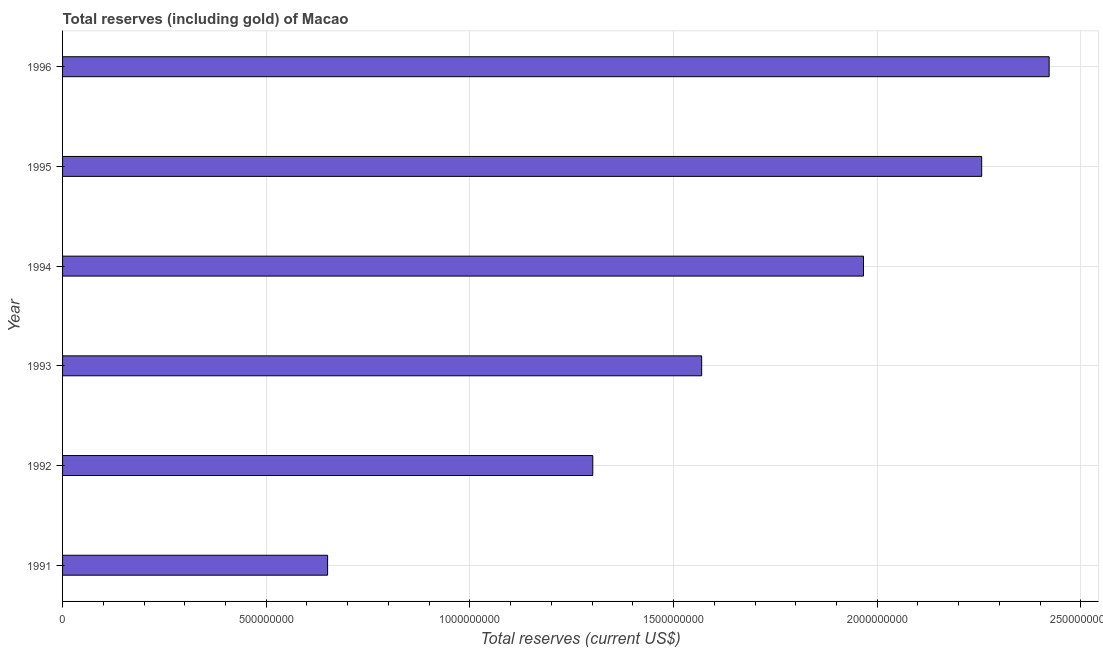Does the graph contain any zero values?
Your answer should be compact. No. Does the graph contain grids?
Your response must be concise. Yes. What is the title of the graph?
Make the answer very short. Total reserves (including gold) of Macao. What is the label or title of the X-axis?
Provide a succinct answer. Total reserves (current US$). What is the label or title of the Y-axis?
Provide a succinct answer. Year. What is the total reserves (including gold) in 1993?
Give a very brief answer. 1.57e+09. Across all years, what is the maximum total reserves (including gold)?
Keep it short and to the point. 2.42e+09. Across all years, what is the minimum total reserves (including gold)?
Provide a short and direct response. 6.51e+08. In which year was the total reserves (including gold) maximum?
Make the answer very short. 1996. In which year was the total reserves (including gold) minimum?
Make the answer very short. 1991. What is the sum of the total reserves (including gold)?
Provide a succinct answer. 1.02e+1. What is the difference between the total reserves (including gold) in 1993 and 1994?
Your answer should be very brief. -3.97e+08. What is the average total reserves (including gold) per year?
Your answer should be compact. 1.69e+09. What is the median total reserves (including gold)?
Give a very brief answer. 1.77e+09. In how many years, is the total reserves (including gold) greater than 1300000000 US$?
Ensure brevity in your answer.  5. What is the ratio of the total reserves (including gold) in 1992 to that in 1995?
Ensure brevity in your answer.  0.58. Is the total reserves (including gold) in 1995 less than that in 1996?
Your answer should be compact. Yes. What is the difference between the highest and the second highest total reserves (including gold)?
Your answer should be compact. 1.66e+08. Is the sum of the total reserves (including gold) in 1993 and 1994 greater than the maximum total reserves (including gold) across all years?
Your answer should be very brief. Yes. What is the difference between the highest and the lowest total reserves (including gold)?
Provide a short and direct response. 1.77e+09. In how many years, is the total reserves (including gold) greater than the average total reserves (including gold) taken over all years?
Provide a short and direct response. 3. How many bars are there?
Give a very brief answer. 6. What is the difference between two consecutive major ticks on the X-axis?
Your answer should be compact. 5.00e+08. Are the values on the major ticks of X-axis written in scientific E-notation?
Provide a short and direct response. No. What is the Total reserves (current US$) in 1991?
Your answer should be very brief. 6.51e+08. What is the Total reserves (current US$) in 1992?
Ensure brevity in your answer.  1.30e+09. What is the Total reserves (current US$) in 1993?
Provide a succinct answer. 1.57e+09. What is the Total reserves (current US$) in 1994?
Ensure brevity in your answer.  1.97e+09. What is the Total reserves (current US$) in 1995?
Provide a short and direct response. 2.26e+09. What is the Total reserves (current US$) of 1996?
Provide a succinct answer. 2.42e+09. What is the difference between the Total reserves (current US$) in 1991 and 1992?
Your answer should be compact. -6.51e+08. What is the difference between the Total reserves (current US$) in 1991 and 1993?
Make the answer very short. -9.18e+08. What is the difference between the Total reserves (current US$) in 1991 and 1994?
Ensure brevity in your answer.  -1.32e+09. What is the difference between the Total reserves (current US$) in 1991 and 1995?
Offer a very short reply. -1.61e+09. What is the difference between the Total reserves (current US$) in 1991 and 1996?
Provide a succinct answer. -1.77e+09. What is the difference between the Total reserves (current US$) in 1992 and 1993?
Your answer should be very brief. -2.67e+08. What is the difference between the Total reserves (current US$) in 1992 and 1994?
Ensure brevity in your answer.  -6.65e+08. What is the difference between the Total reserves (current US$) in 1992 and 1995?
Provide a succinct answer. -9.55e+08. What is the difference between the Total reserves (current US$) in 1992 and 1996?
Provide a succinct answer. -1.12e+09. What is the difference between the Total reserves (current US$) in 1993 and 1994?
Offer a terse response. -3.97e+08. What is the difference between the Total reserves (current US$) in 1993 and 1995?
Your answer should be very brief. -6.87e+08. What is the difference between the Total reserves (current US$) in 1993 and 1996?
Your answer should be compact. -8.53e+08. What is the difference between the Total reserves (current US$) in 1994 and 1995?
Your answer should be very brief. -2.90e+08. What is the difference between the Total reserves (current US$) in 1994 and 1996?
Ensure brevity in your answer.  -4.56e+08. What is the difference between the Total reserves (current US$) in 1995 and 1996?
Ensure brevity in your answer.  -1.66e+08. What is the ratio of the Total reserves (current US$) in 1991 to that in 1992?
Provide a succinct answer. 0.5. What is the ratio of the Total reserves (current US$) in 1991 to that in 1993?
Give a very brief answer. 0.41. What is the ratio of the Total reserves (current US$) in 1991 to that in 1994?
Your response must be concise. 0.33. What is the ratio of the Total reserves (current US$) in 1991 to that in 1995?
Make the answer very short. 0.29. What is the ratio of the Total reserves (current US$) in 1991 to that in 1996?
Keep it short and to the point. 0.27. What is the ratio of the Total reserves (current US$) in 1992 to that in 1993?
Offer a terse response. 0.83. What is the ratio of the Total reserves (current US$) in 1992 to that in 1994?
Keep it short and to the point. 0.66. What is the ratio of the Total reserves (current US$) in 1992 to that in 1995?
Provide a short and direct response. 0.58. What is the ratio of the Total reserves (current US$) in 1992 to that in 1996?
Provide a short and direct response. 0.54. What is the ratio of the Total reserves (current US$) in 1993 to that in 1994?
Offer a very short reply. 0.8. What is the ratio of the Total reserves (current US$) in 1993 to that in 1995?
Provide a succinct answer. 0.69. What is the ratio of the Total reserves (current US$) in 1993 to that in 1996?
Provide a succinct answer. 0.65. What is the ratio of the Total reserves (current US$) in 1994 to that in 1995?
Your answer should be compact. 0.87. What is the ratio of the Total reserves (current US$) in 1994 to that in 1996?
Provide a succinct answer. 0.81. What is the ratio of the Total reserves (current US$) in 1995 to that in 1996?
Give a very brief answer. 0.93. 